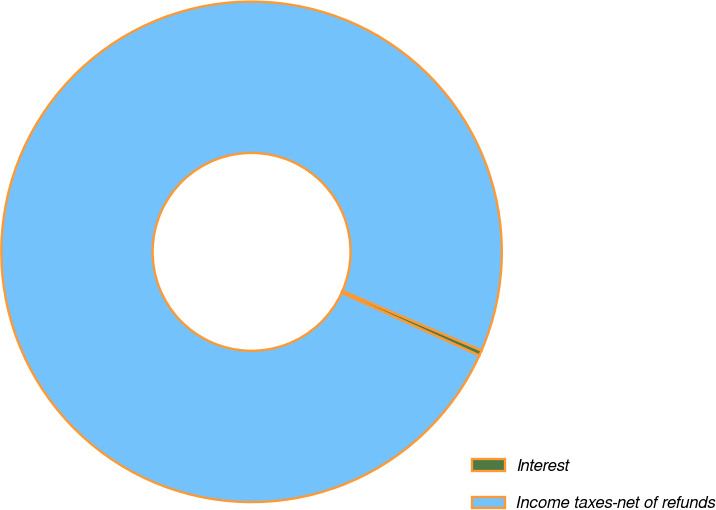Convert chart. <chart><loc_0><loc_0><loc_500><loc_500><pie_chart><fcel>Interest<fcel>Income taxes-net of refunds<nl><fcel>0.35%<fcel>99.65%<nl></chart> 